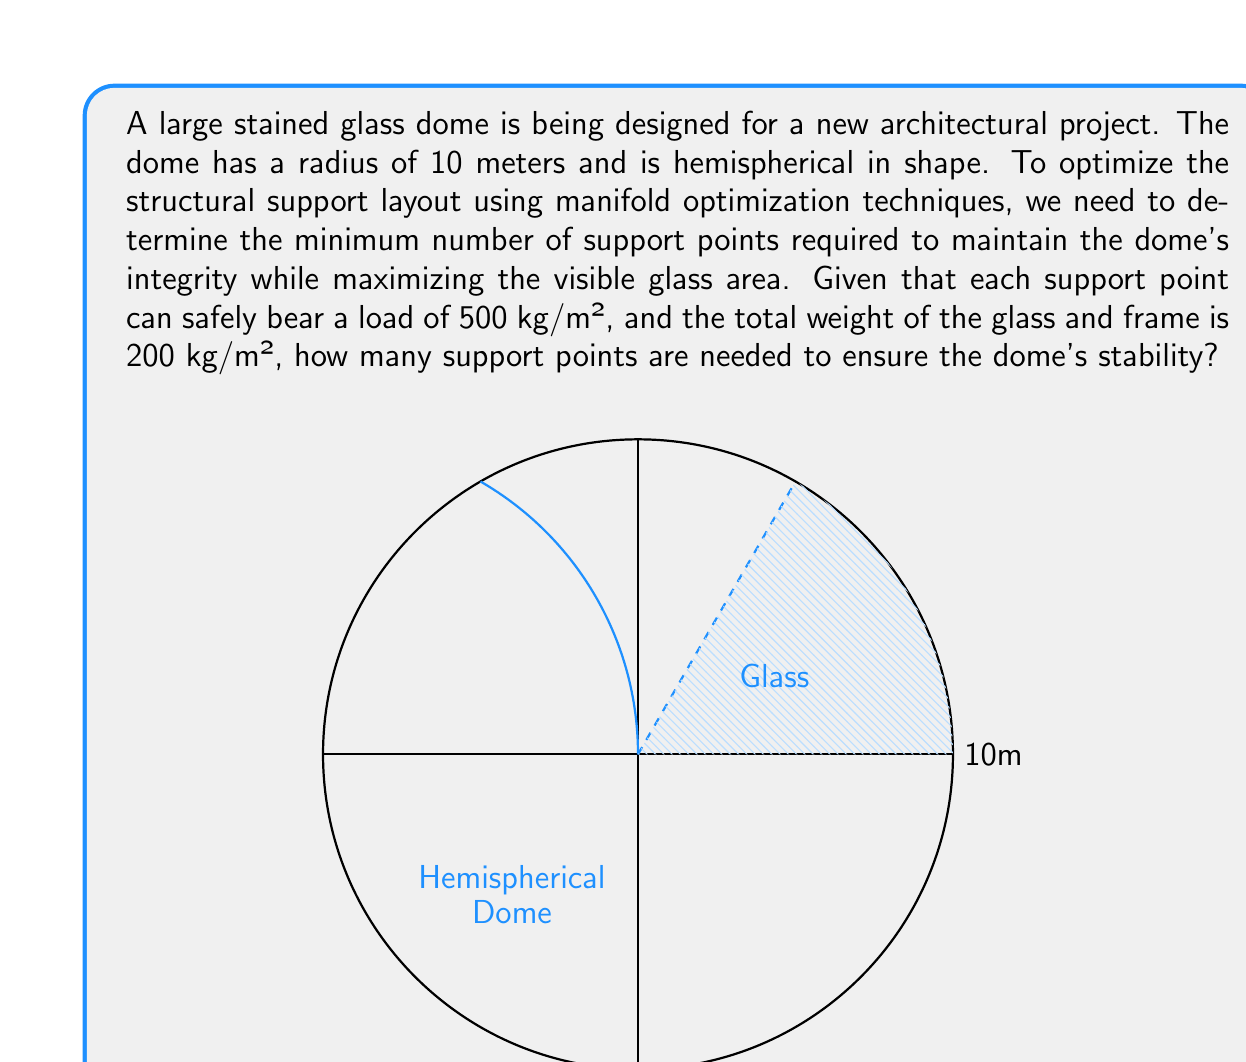Give your solution to this math problem. Let's approach this step-by-step:

1) First, we need to calculate the surface area of the hemispherical dome:
   $$A = 2\pi r^2$$
   where $r$ is the radius of the dome.
   $$A = 2\pi (10\text{m})^2 = 200\pi \text{ m}^2$$

2) Now, let's calculate the total weight of the dome:
   $$W = 200 \text{ kg/m}^2 \times 200\pi \text{ m}^2 = 40000\pi \text{ kg}$$

3) Each support point can bear 500 kg/m². We need to find how much area each point can support:
   $$A_{\text{support}} = \frac{500 \text{ kg/m}^2}{200 \text{ kg/m}^2} = 2.5 \text{ m}^2$$

4) To find the number of support points, we divide the total area by the area each point can support:
   $$N = \frac{200\pi \text{ m}^2}{2.5 \text{ m}^2} = 80\pi$$

5) Since we can't have a fractional number of support points, we need to round up to the nearest whole number:
   $$N = \lceil 80\pi \rceil = 252$$

This solution provides the minimum number of support points needed to ensure the dome's stability while maximizing the visible glass area, which is a key consideration in manifold optimization for this structural problem.
Answer: 252 support points 